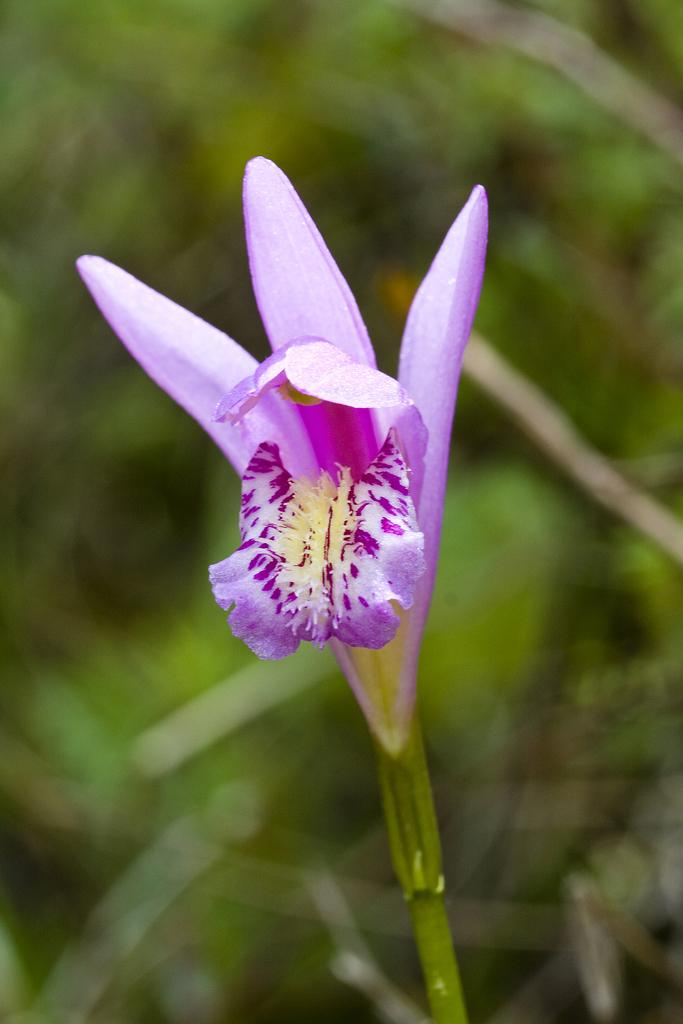What is the main subject in the front of the image? There is a flower in the front of the image. What can be seen in the background of the image? There are leaves in the background of the image. How would you describe the appearance of the background? The background appears blurry. Is there a rat hiding under the leaves in the background? There is no rat present in the image; it only features a flower and leaves. 